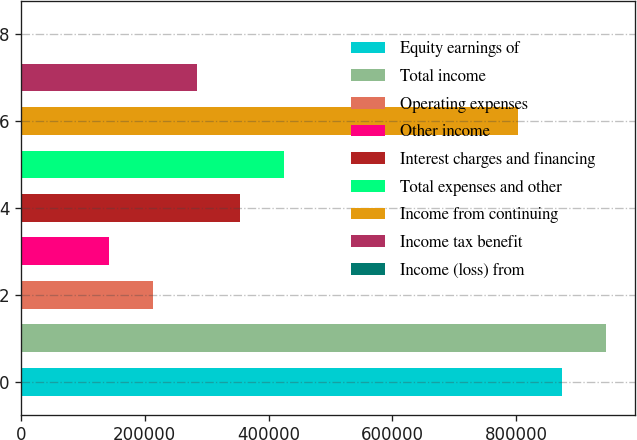Convert chart to OTSL. <chart><loc_0><loc_0><loc_500><loc_500><bar_chart><fcel>Equity earnings of<fcel>Total income<fcel>Operating expenses<fcel>Other income<fcel>Interest charges and financing<fcel>Total expenses and other<fcel>Income from continuing<fcel>Income tax benefit<fcel>Income (loss) from<nl><fcel>873959<fcel>944836<fcel>212799<fcel>141921<fcel>354554<fcel>425432<fcel>803081<fcel>283677<fcel>166<nl></chart> 